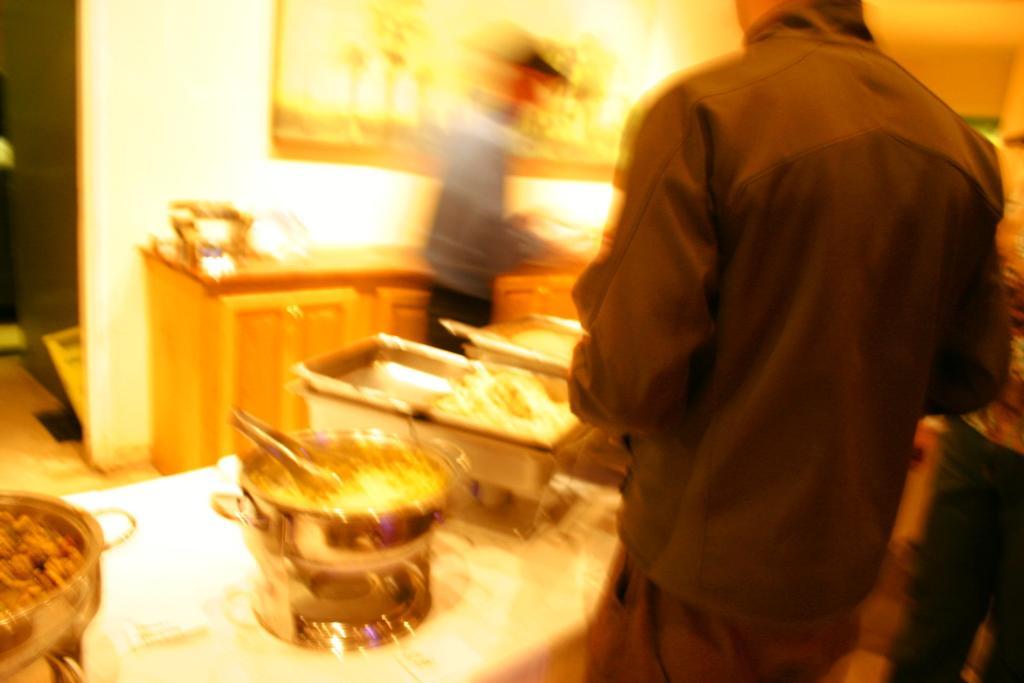Can you describe this image briefly? In front of the picture, we see a man in black shirt is standing. In front of him, we see a table on which serving bowls containing food are placed. Behind that, we see a man in grey shirt is standing. Behind him, we see a table. Behind that, we see a white wall on which photo frame is placed. This picture is blurred in the background. 